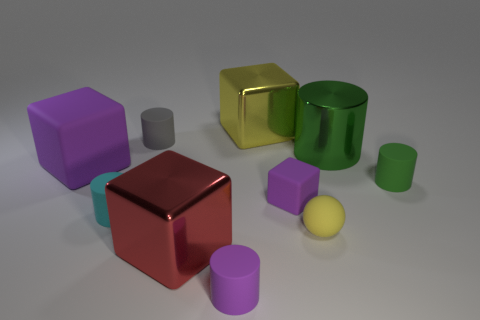Subtract all yellow cylinders. How many purple blocks are left? 2 Subtract all small rubber cylinders. How many cylinders are left? 1 Subtract 1 blocks. How many blocks are left? 3 Subtract all yellow blocks. How many blocks are left? 3 Subtract all brown cylinders. Subtract all purple blocks. How many cylinders are left? 5 Subtract all balls. How many objects are left? 9 Add 1 small green rubber things. How many small green rubber things are left? 2 Add 9 small purple shiny cylinders. How many small purple shiny cylinders exist? 9 Subtract 0 cyan blocks. How many objects are left? 10 Subtract all yellow blocks. Subtract all large red blocks. How many objects are left? 8 